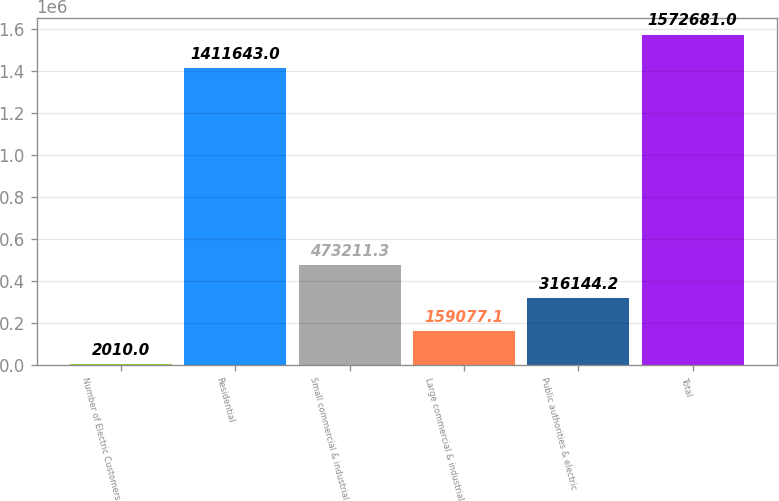<chart> <loc_0><loc_0><loc_500><loc_500><bar_chart><fcel>Number of Electric Customers<fcel>Residential<fcel>Small commercial & industrial<fcel>Large commercial & industrial<fcel>Public authorities & electric<fcel>Total<nl><fcel>2010<fcel>1.41164e+06<fcel>473211<fcel>159077<fcel>316144<fcel>1.57268e+06<nl></chart> 